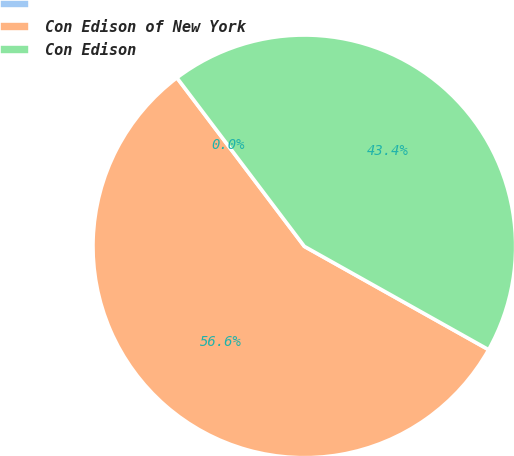Convert chart. <chart><loc_0><loc_0><loc_500><loc_500><pie_chart><ecel><fcel>Con Edison of New York<fcel>Con Edison<nl><fcel>0.0%<fcel>56.57%<fcel>43.43%<nl></chart> 